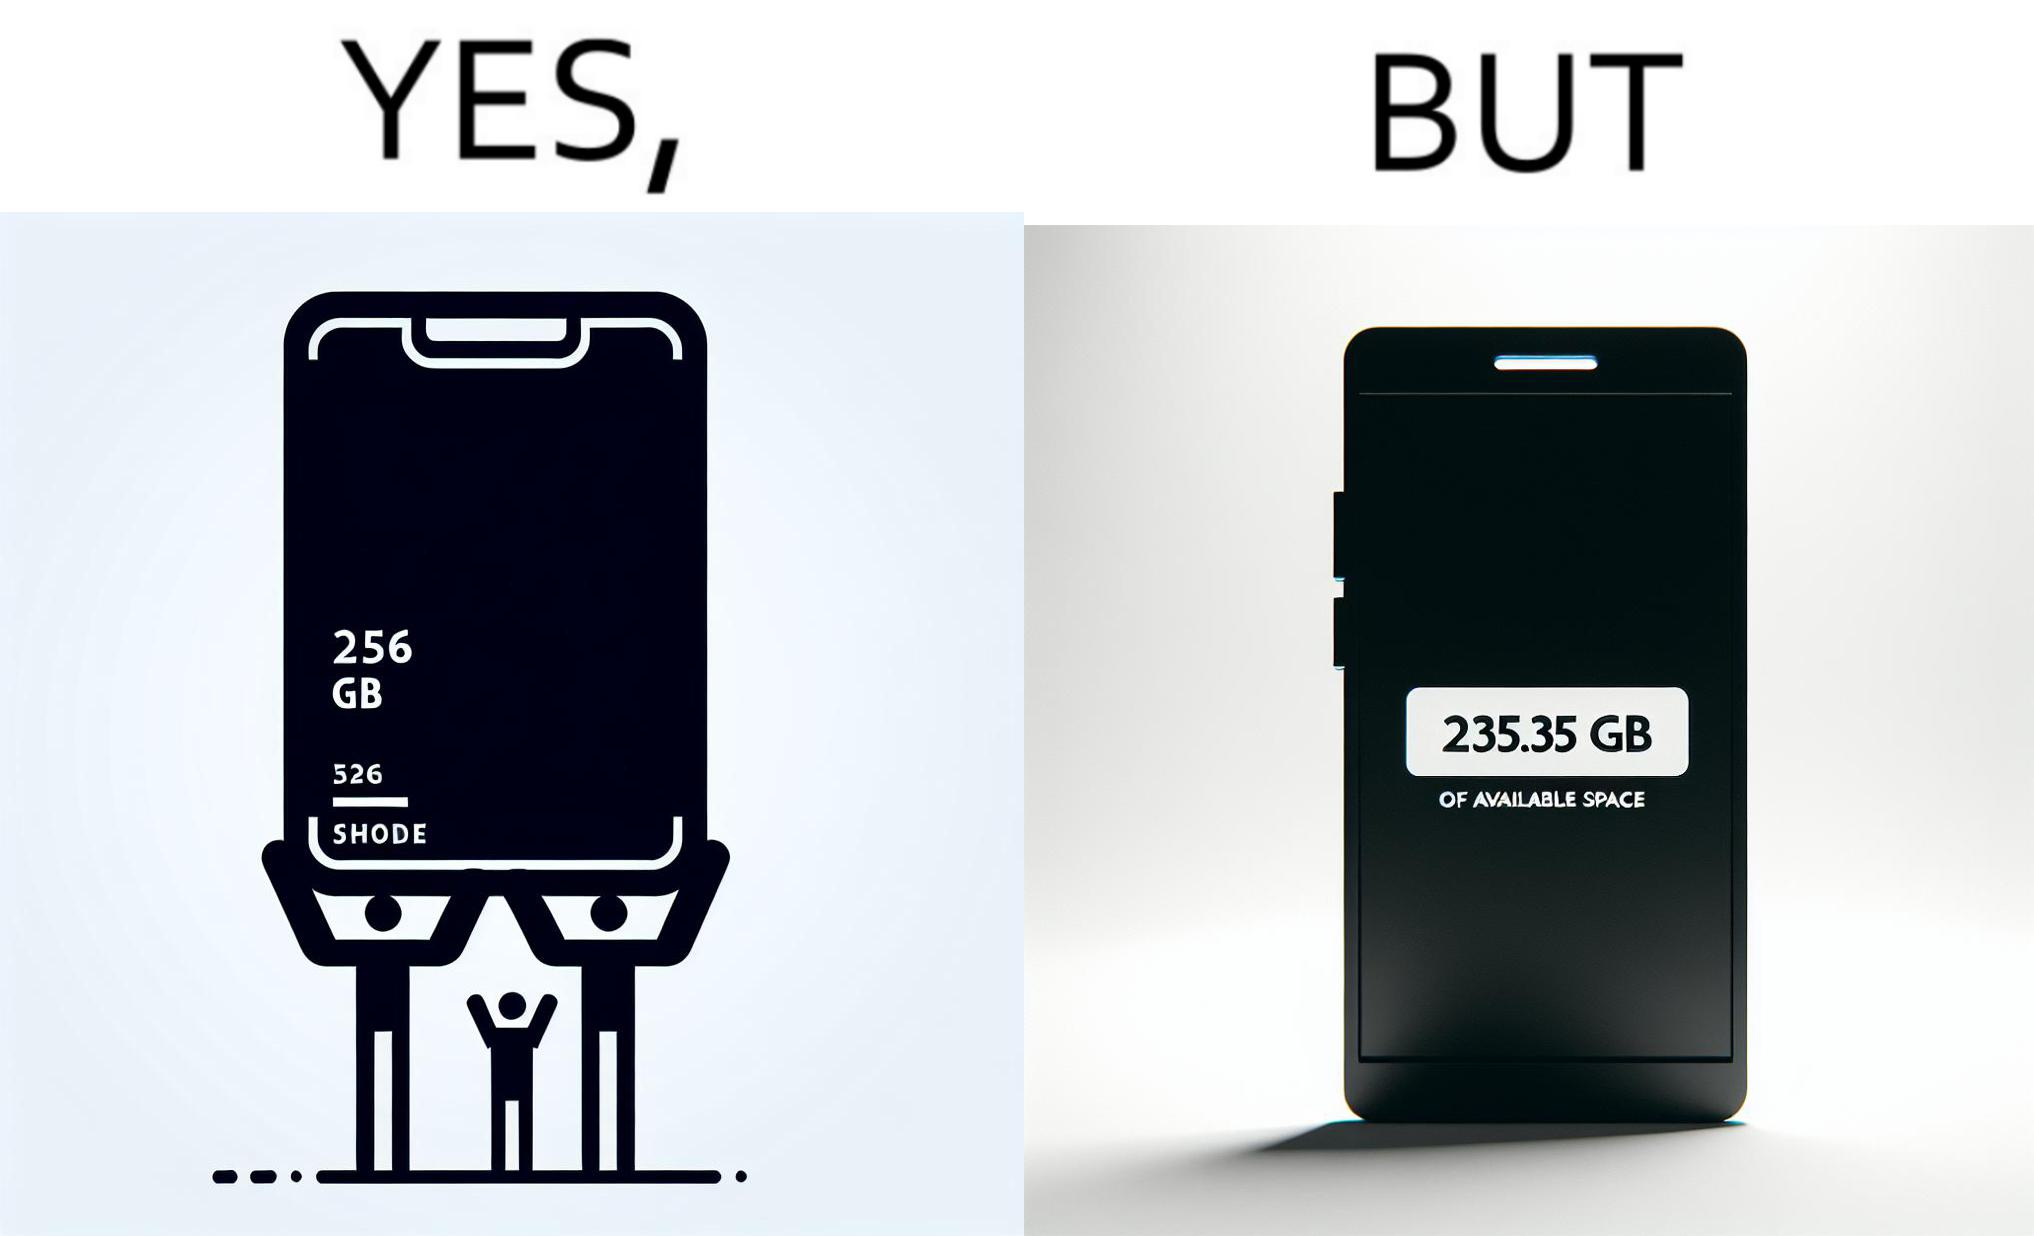Describe the content of this image. The images are funny since they show how smartphone manufacturers advertise their smartphones to have a high internal storage space but in reality, the amount of space available to an user is considerably less due to pre-installed software 